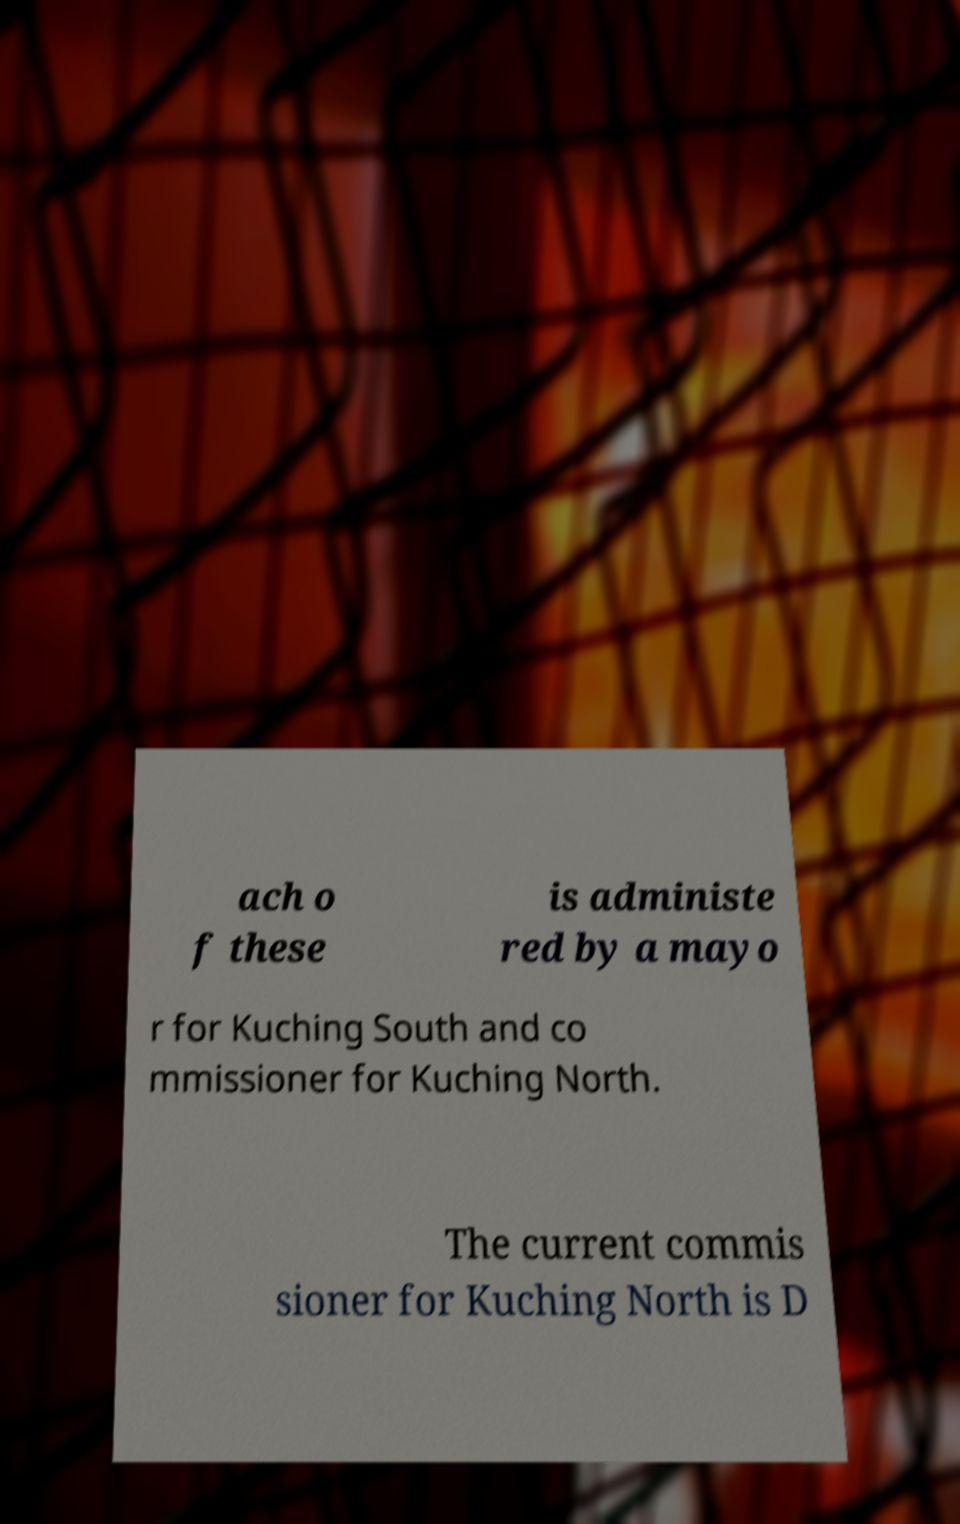For documentation purposes, I need the text within this image transcribed. Could you provide that? ach o f these is administe red by a mayo r for Kuching South and co mmissioner for Kuching North. The current commis sioner for Kuching North is D 